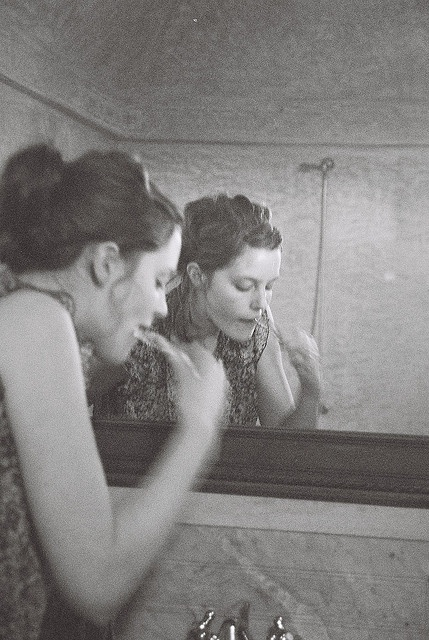Describe the objects in this image and their specific colors. I can see people in gray, darkgray, and black tones, people in gray, darkgray, lightgray, and black tones, toothbrush in gray, darkgray, and lightgray tones, and toothbrush in gray, darkgray, and lightgray tones in this image. 